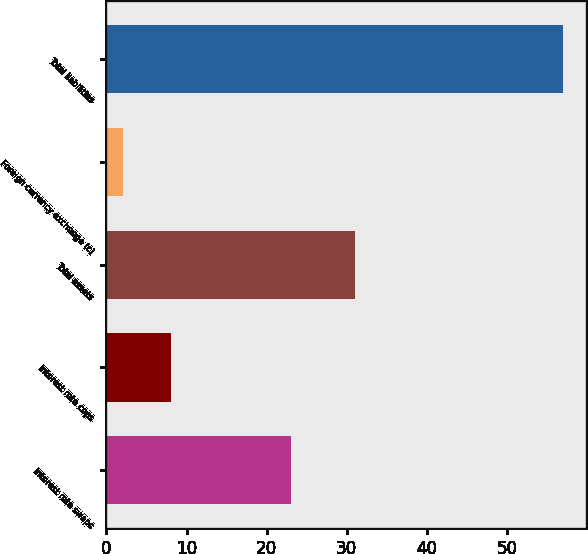Convert chart to OTSL. <chart><loc_0><loc_0><loc_500><loc_500><bar_chart><fcel>Interest rate swaps<fcel>Interest rate caps<fcel>Total assets<fcel>Foreign currency exchange (c)<fcel>Total liabilities<nl><fcel>23<fcel>8<fcel>31<fcel>2<fcel>57<nl></chart> 